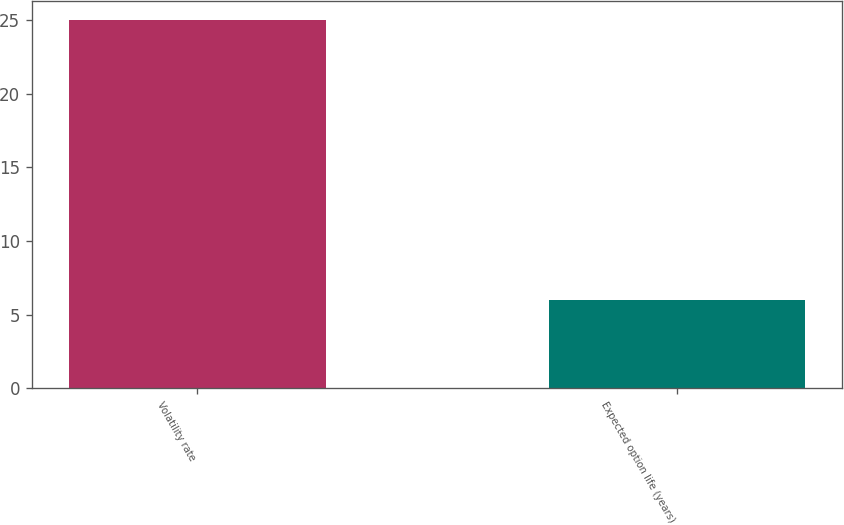Convert chart to OTSL. <chart><loc_0><loc_0><loc_500><loc_500><bar_chart><fcel>Volatility rate<fcel>Expected option life (years)<nl><fcel>25<fcel>6<nl></chart> 